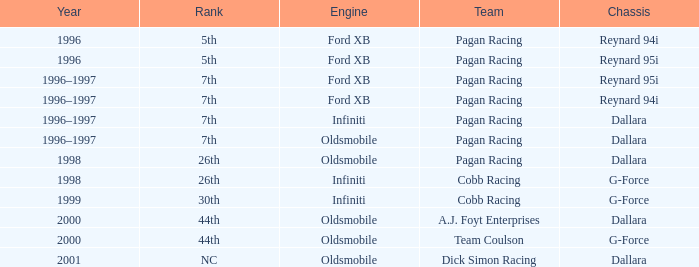Write the full table. {'header': ['Year', 'Rank', 'Engine', 'Team', 'Chassis'], 'rows': [['1996', '5th', 'Ford XB', 'Pagan Racing', 'Reynard 94i'], ['1996', '5th', 'Ford XB', 'Pagan Racing', 'Reynard 95i'], ['1996–1997', '7th', 'Ford XB', 'Pagan Racing', 'Reynard 95i'], ['1996–1997', '7th', 'Ford XB', 'Pagan Racing', 'Reynard 94i'], ['1996–1997', '7th', 'Infiniti', 'Pagan Racing', 'Dallara'], ['1996–1997', '7th', 'Oldsmobile', 'Pagan Racing', 'Dallara'], ['1998', '26th', 'Oldsmobile', 'Pagan Racing', 'Dallara'], ['1998', '26th', 'Infiniti', 'Cobb Racing', 'G-Force'], ['1999', '30th', 'Infiniti', 'Cobb Racing', 'G-Force'], ['2000', '44th', 'Oldsmobile', 'A.J. Foyt Enterprises', 'Dallara'], ['2000', '44th', 'Oldsmobile', 'Team Coulson', 'G-Force'], ['2001', 'NC', 'Oldsmobile', 'Dick Simon Racing', 'Dallara']]} Which engine finished 7th with the reynard 95i chassis? Ford XB. 